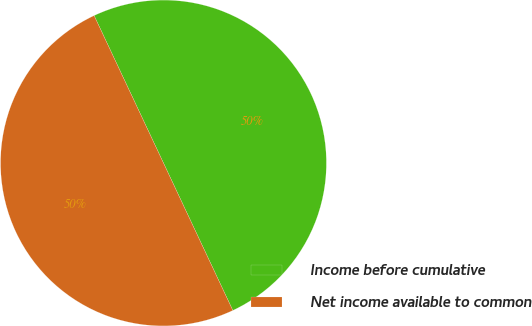Convert chart to OTSL. <chart><loc_0><loc_0><loc_500><loc_500><pie_chart><fcel>Income before cumulative<fcel>Net income available to common<nl><fcel>50.0%<fcel>50.0%<nl></chart> 